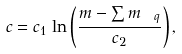Convert formula to latex. <formula><loc_0><loc_0><loc_500><loc_500>c = c _ { 1 } \, \ln \left ( \frac { m - \sum m _ { \ q } } { c _ { 2 } } \right ) ,</formula> 